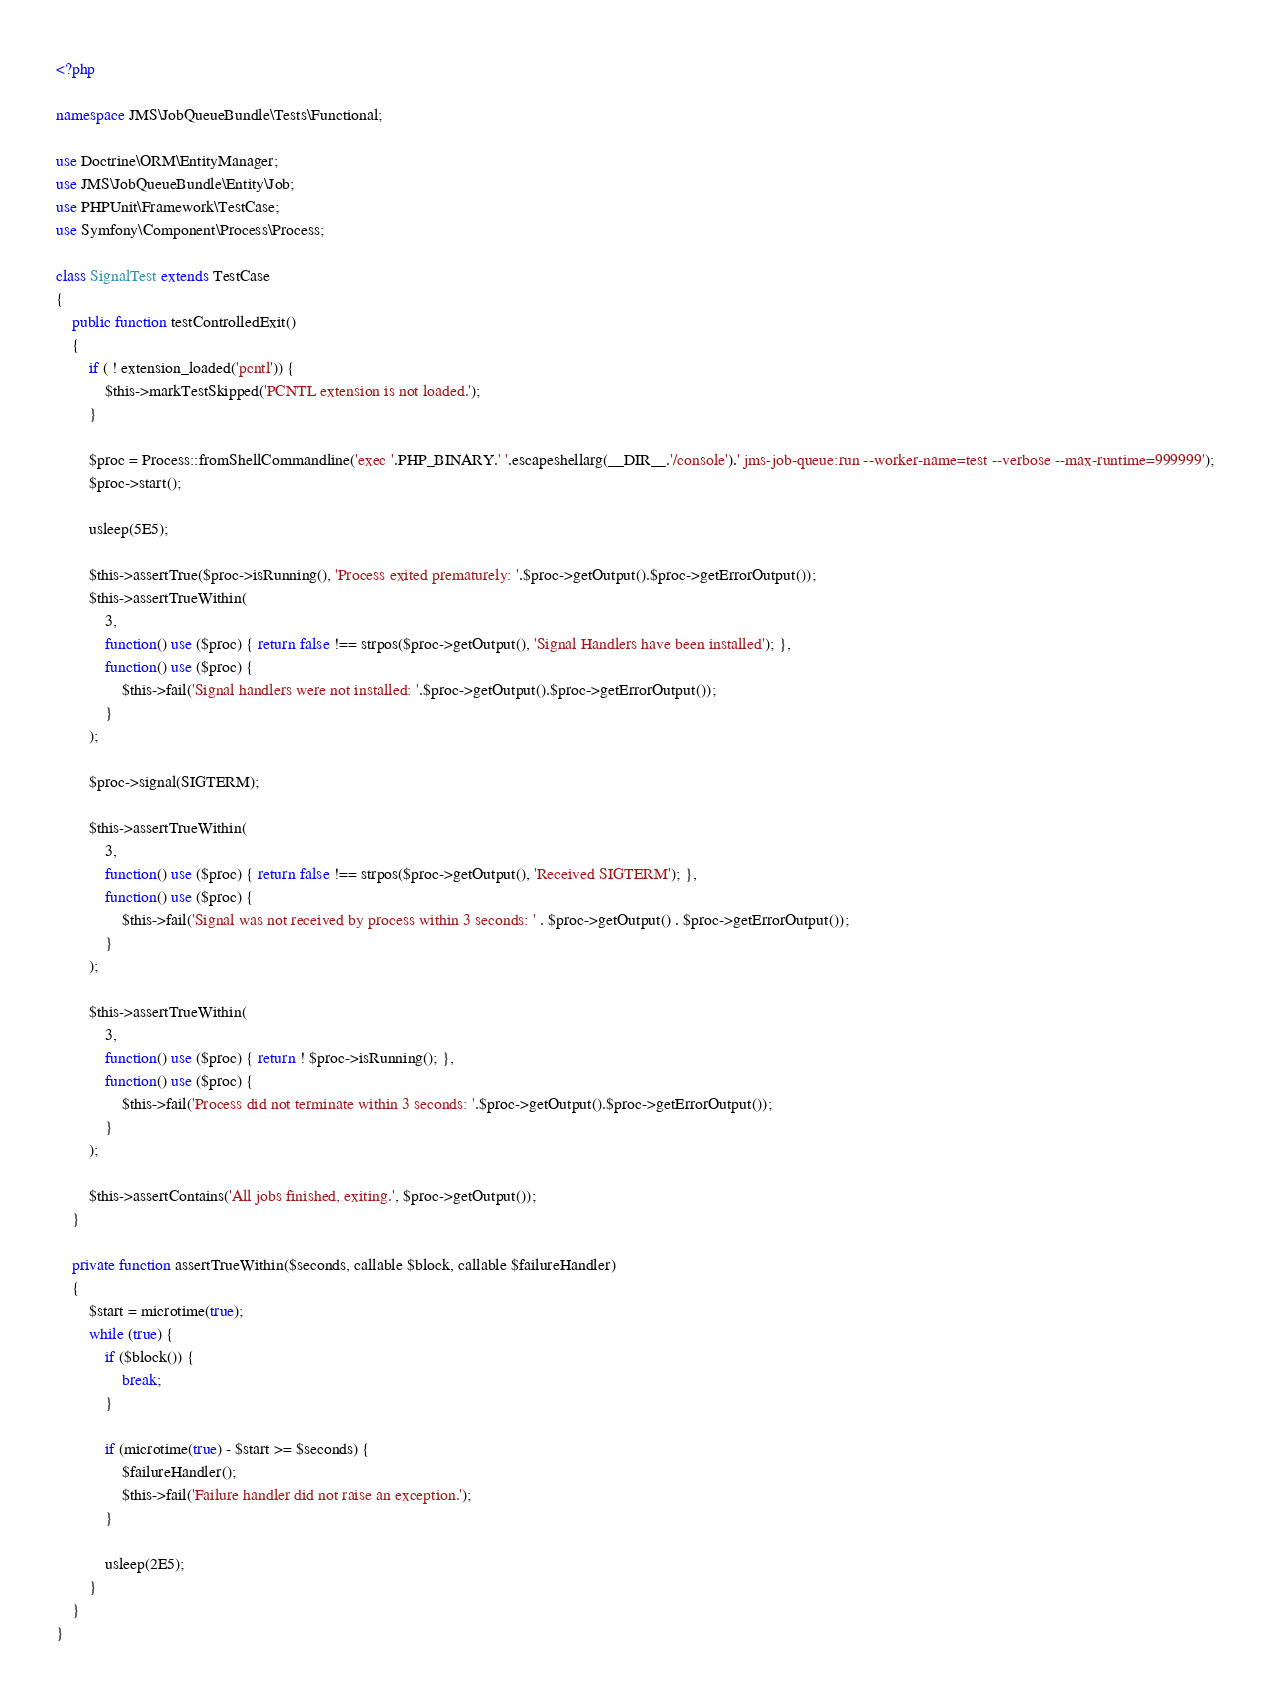Convert code to text. <code><loc_0><loc_0><loc_500><loc_500><_PHP_><?php

namespace JMS\JobQueueBundle\Tests\Functional;

use Doctrine\ORM\EntityManager;
use JMS\JobQueueBundle\Entity\Job;
use PHPUnit\Framework\TestCase;
use Symfony\Component\Process\Process;

class SignalTest extends TestCase
{
    public function testControlledExit()
    {
        if ( ! extension_loaded('pcntl')) {
            $this->markTestSkipped('PCNTL extension is not loaded.');
        }

        $proc = Process::fromShellCommandline('exec '.PHP_BINARY.' '.escapeshellarg(__DIR__.'/console').' jms-job-queue:run --worker-name=test --verbose --max-runtime=999999');
        $proc->start();

        usleep(5E5);

        $this->assertTrue($proc->isRunning(), 'Process exited prematurely: '.$proc->getOutput().$proc->getErrorOutput());
        $this->assertTrueWithin(
            3,
            function() use ($proc) { return false !== strpos($proc->getOutput(), 'Signal Handlers have been installed'); },
            function() use ($proc) {
                $this->fail('Signal handlers were not installed: '.$proc->getOutput().$proc->getErrorOutput());
            }
        );

        $proc->signal(SIGTERM);

        $this->assertTrueWithin(
            3,
            function() use ($proc) { return false !== strpos($proc->getOutput(), 'Received SIGTERM'); },
            function() use ($proc) {
                $this->fail('Signal was not received by process within 3 seconds: ' . $proc->getOutput() . $proc->getErrorOutput());
            }
        );

        $this->assertTrueWithin(
            3,
            function() use ($proc) { return ! $proc->isRunning(); },
            function() use ($proc) {
                $this->fail('Process did not terminate within 3 seconds: '.$proc->getOutput().$proc->getErrorOutput());
            }
        );

        $this->assertContains('All jobs finished, exiting.', $proc->getOutput());
    }

    private function assertTrueWithin($seconds, callable $block, callable $failureHandler)
    {
        $start = microtime(true);
        while (true) {
            if ($block()) {
                break;
            }

            if (microtime(true) - $start >= $seconds) {
                $failureHandler();
                $this->fail('Failure handler did not raise an exception.');
            }

            usleep(2E5);
        }
    }
}</code> 